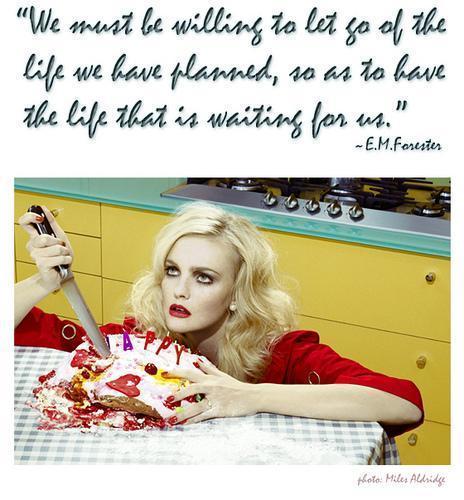How many rolls of toilet paper are on the toilet?
Give a very brief answer. 0. 